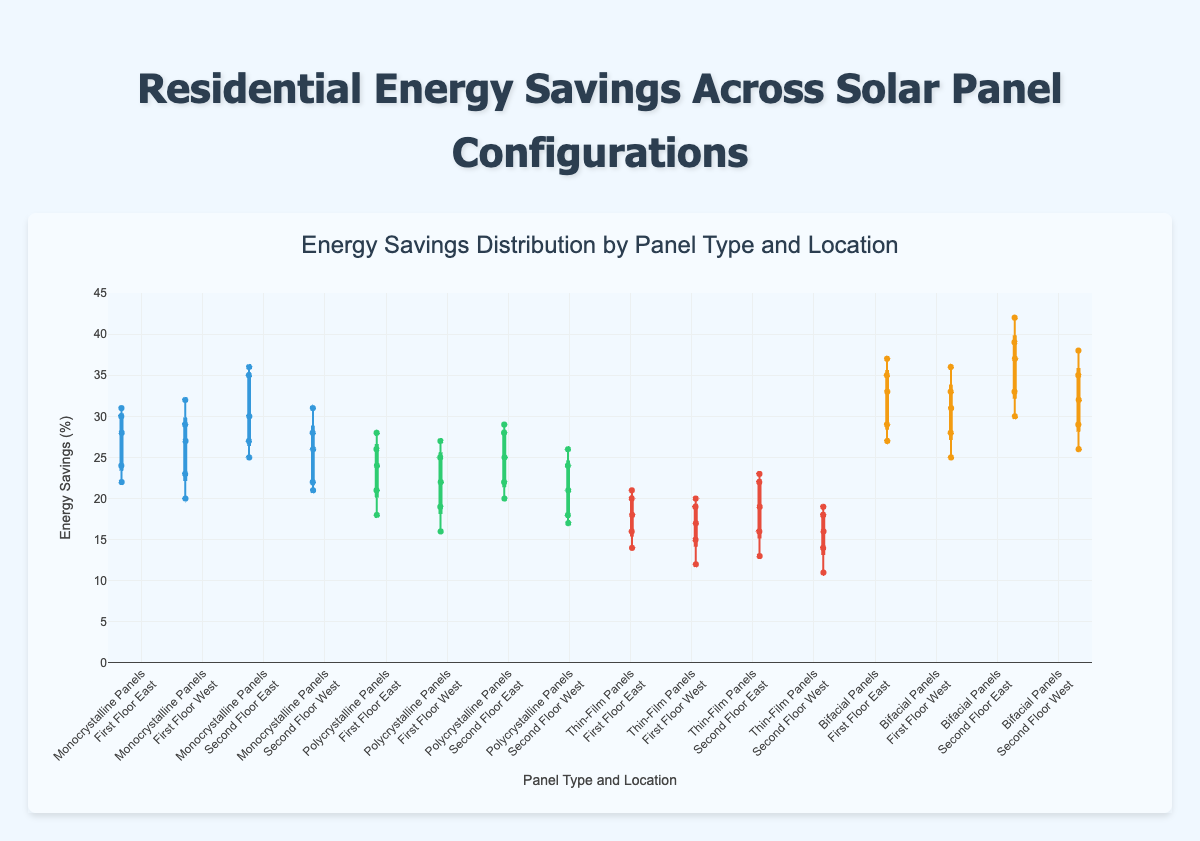What is the title of the figure? The title is located at the top of the figure and summarizes the content of the plot.
Answer: Energy Savings Distribution by Panel Type and Location What does the y-axis represent? The y-axis label indicates the variable measured, which in this plot is the percentage of energy savings.
Answer: Energy Savings (%) Which solar panel configuration has the highest median savings? By referring to the middle line in each box plot, the Bifacial Panels on the Second Floor East category has the highest median value as its middle line is at approximately 37-38%.
Answer: Bifacial Panels on the Second Floor East How do the energy savings of Monocrystalline Panels on the First Floor East compare to those on the First Floor West? Compare the box plots for "Monocrystalline Panels" on "First Floor East" and "First Floor West". The First Floor East has a slightly higher spread with a median around 28-29%, while the First Floor West has a median around 27-28%. Both ranges are similar, but First Floor East shows a slightly higher central tendency.
Answer: First Floor East has slightly higher median What is the range of energy savings for Polycrystalline Panels on the Second Floor East? The range is determined by the minimum and maximum points depicted by the whiskers of the box plot. The minimum is around 20% and the maximum is around 29%.
Answer: 20% to 29% Which solar panel configuration and location has the largest spread of energy savings? Look for the box plot with the widest box and largest distance between the whiskers. The Bifacial Panels on the Second Floor East have the largest spread from around 30% to 42%.
Answer: Bifacial Panels on the Second Floor East Are the energy savings generally higher on the second floor compared to the first floor for all types of panels? By comparing the box plots, we observe that for most panels like Monocrystalline and Bifacial Panels, the second floor locations have higher medians and ranges. The visual trend supports higher savings on the second floor.
Answer: Yes, generally higher on the second floor Which panel configuration on the Second Floor East location shows the lowest median energy savings? Look at the median lines within the box plots for the Second Floor East location across all the panel types. The Thin-Film Panels on the Second Floor East show the lowest median around 19-20%.
Answer: Thin-Film Panels on the Second Floor East How do the energy savings of Thin-Film Panels vary by floor and direction? Analyze the distribution and medians of the box plots for Thin-Film Panels on different floors and directions. First Floor East and Second Floor East show similar variability but Second Floor East has a higher median. First Floor West and Second Floor West also follow this trend but with smaller ranges.
Answer: Higher on the second floor, more spread on the east Which configuration and location show the highest variation in energy savings? The highest variation corresponds to the largest interquartile range and whisker length. Bifacial Panels on the Second Floor East exhibit the highest variation, with a wider box and longer whiskers.
Answer: Bifacial Panels on the Second Floor East What can you infer about the energy savings differences between Monocrystalline and Polycrystalline Panels? Compare the box plots for each floor and direction between the two panel types. Monocrystalline Panels generally have higher medians and slightly larger ranges compared to Polycrystalline Panels across all locations.
Answer: Monocrystalline Panels generally have higher savings 